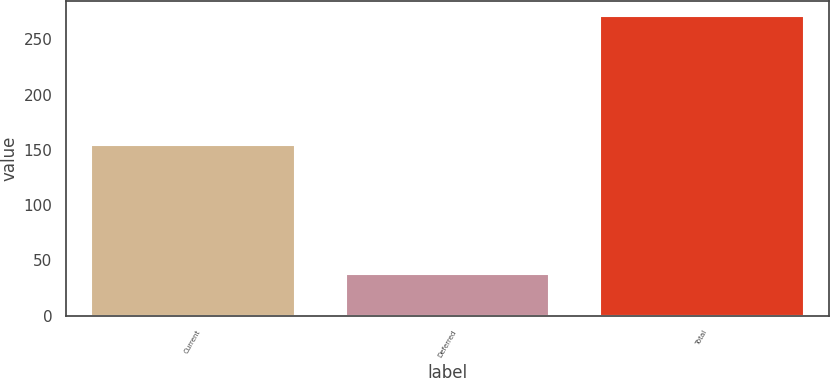<chart> <loc_0><loc_0><loc_500><loc_500><bar_chart><fcel>Current<fcel>Deferred<fcel>Total<nl><fcel>154.1<fcel>37.6<fcel>271.3<nl></chart> 